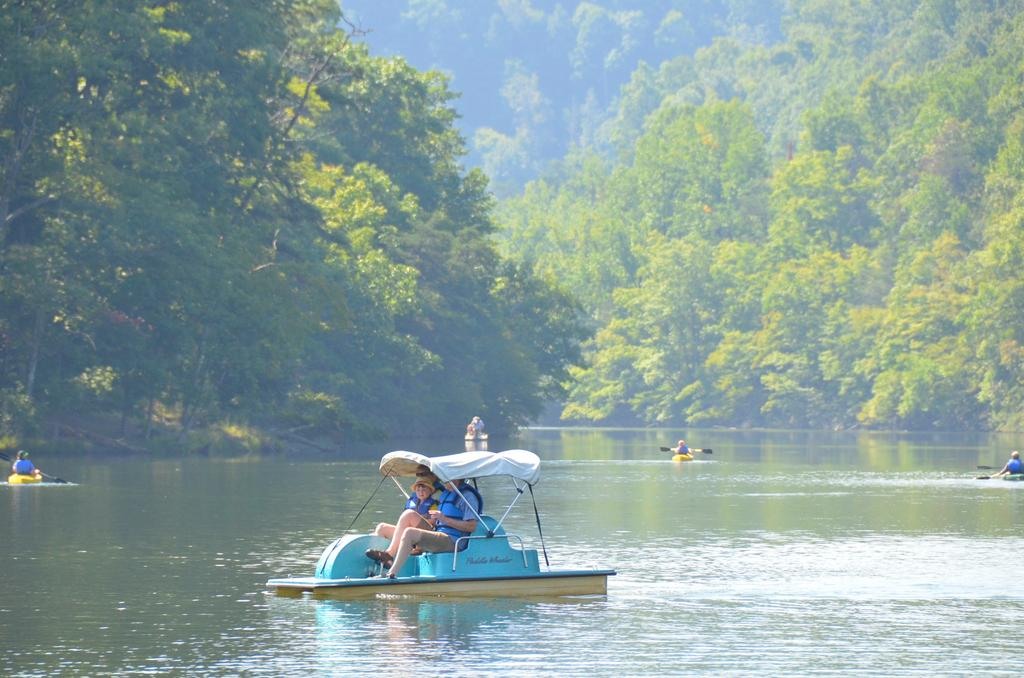What are the people in the image doing? There are people sitting in a boat in the image. What can be seen happening in the background of the image? In the background, there are persons rowing boats on the water. What type of natural scenery is visible in the image? Trees are visible at the top of the image. What type of yard is visible in the image? There is no yard visible in the image; it features people in a boat and persons rowing boats on the water, with trees in the background. 